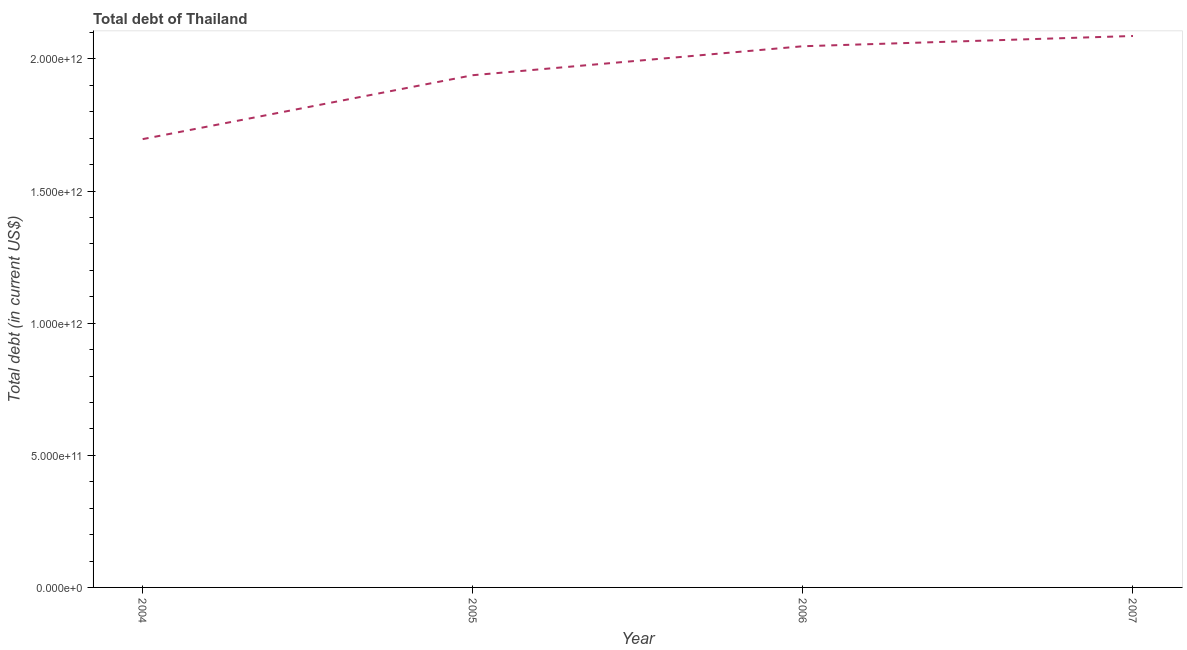What is the total debt in 2004?
Give a very brief answer. 1.70e+12. Across all years, what is the maximum total debt?
Offer a terse response. 2.09e+12. Across all years, what is the minimum total debt?
Offer a very short reply. 1.70e+12. What is the sum of the total debt?
Your response must be concise. 7.77e+12. What is the difference between the total debt in 2005 and 2007?
Your answer should be very brief. -1.48e+11. What is the average total debt per year?
Your response must be concise. 1.94e+12. What is the median total debt?
Make the answer very short. 1.99e+12. Do a majority of the years between 2006 and 2005 (inclusive) have total debt greater than 1200000000000 US$?
Give a very brief answer. No. What is the ratio of the total debt in 2005 to that in 2007?
Offer a very short reply. 0.93. What is the difference between the highest and the second highest total debt?
Your response must be concise. 3.88e+1. Is the sum of the total debt in 2005 and 2007 greater than the maximum total debt across all years?
Keep it short and to the point. Yes. What is the difference between the highest and the lowest total debt?
Make the answer very short. 3.90e+11. In how many years, is the total debt greater than the average total debt taken over all years?
Your answer should be very brief. 2. How many lines are there?
Ensure brevity in your answer.  1. What is the difference between two consecutive major ticks on the Y-axis?
Make the answer very short. 5.00e+11. Are the values on the major ticks of Y-axis written in scientific E-notation?
Give a very brief answer. Yes. Does the graph contain grids?
Your answer should be compact. No. What is the title of the graph?
Provide a succinct answer. Total debt of Thailand. What is the label or title of the Y-axis?
Give a very brief answer. Total debt (in current US$). What is the Total debt (in current US$) in 2004?
Make the answer very short. 1.70e+12. What is the Total debt (in current US$) in 2005?
Give a very brief answer. 1.94e+12. What is the Total debt (in current US$) in 2006?
Ensure brevity in your answer.  2.05e+12. What is the Total debt (in current US$) of 2007?
Make the answer very short. 2.09e+12. What is the difference between the Total debt (in current US$) in 2004 and 2005?
Your answer should be compact. -2.42e+11. What is the difference between the Total debt (in current US$) in 2004 and 2006?
Offer a terse response. -3.52e+11. What is the difference between the Total debt (in current US$) in 2004 and 2007?
Your response must be concise. -3.90e+11. What is the difference between the Total debt (in current US$) in 2005 and 2006?
Provide a short and direct response. -1.10e+11. What is the difference between the Total debt (in current US$) in 2005 and 2007?
Ensure brevity in your answer.  -1.48e+11. What is the difference between the Total debt (in current US$) in 2006 and 2007?
Ensure brevity in your answer.  -3.88e+1. What is the ratio of the Total debt (in current US$) in 2004 to that in 2005?
Give a very brief answer. 0.88. What is the ratio of the Total debt (in current US$) in 2004 to that in 2006?
Offer a very short reply. 0.83. What is the ratio of the Total debt (in current US$) in 2004 to that in 2007?
Your answer should be compact. 0.81. What is the ratio of the Total debt (in current US$) in 2005 to that in 2006?
Your answer should be compact. 0.95. What is the ratio of the Total debt (in current US$) in 2005 to that in 2007?
Ensure brevity in your answer.  0.93. 